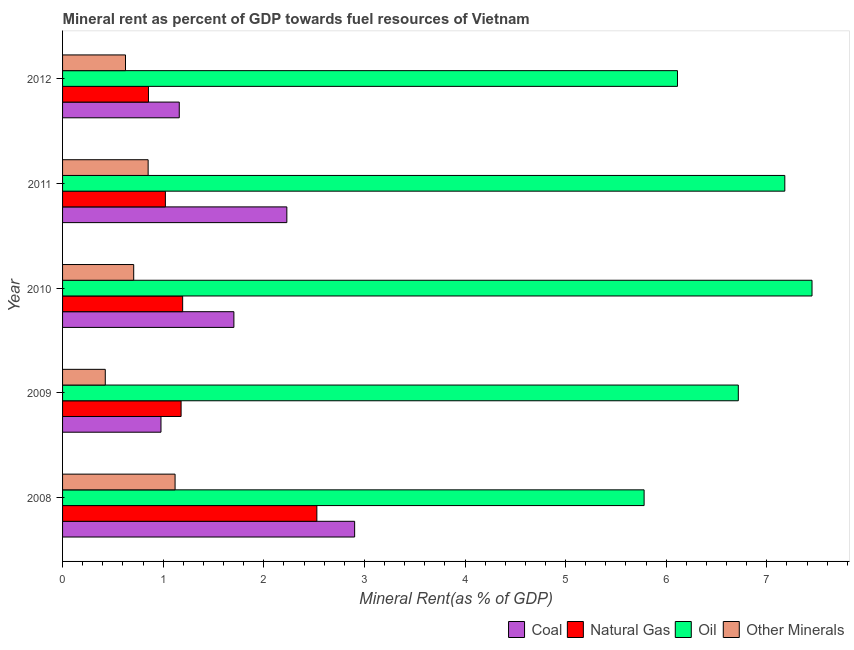How many different coloured bars are there?
Provide a succinct answer. 4. Are the number of bars on each tick of the Y-axis equal?
Offer a terse response. Yes. In how many cases, is the number of bars for a given year not equal to the number of legend labels?
Give a very brief answer. 0. What is the oil rent in 2011?
Provide a short and direct response. 7.18. Across all years, what is the maximum oil rent?
Offer a terse response. 7.45. Across all years, what is the minimum coal rent?
Provide a short and direct response. 0.98. What is the total oil rent in the graph?
Keep it short and to the point. 33.24. What is the difference between the natural gas rent in 2010 and that in 2011?
Make the answer very short. 0.17. What is the difference between the natural gas rent in 2009 and the oil rent in 2011?
Offer a very short reply. -6. What is the average natural gas rent per year?
Give a very brief answer. 1.35. In the year 2008, what is the difference between the oil rent and natural gas rent?
Ensure brevity in your answer.  3.25. What is the ratio of the  rent of other minerals in 2011 to that in 2012?
Offer a very short reply. 1.36. Is the natural gas rent in 2009 less than that in 2012?
Offer a terse response. No. Is the difference between the natural gas rent in 2008 and 2009 greater than the difference between the  rent of other minerals in 2008 and 2009?
Offer a terse response. Yes. What is the difference between the highest and the second highest natural gas rent?
Keep it short and to the point. 1.33. What is the difference between the highest and the lowest coal rent?
Provide a short and direct response. 1.92. What does the 3rd bar from the top in 2008 represents?
Make the answer very short. Natural Gas. What does the 1st bar from the bottom in 2010 represents?
Your answer should be very brief. Coal. Is it the case that in every year, the sum of the coal rent and natural gas rent is greater than the oil rent?
Ensure brevity in your answer.  No. How many years are there in the graph?
Give a very brief answer. 5. Are the values on the major ticks of X-axis written in scientific E-notation?
Your response must be concise. No. Does the graph contain any zero values?
Your response must be concise. No. Does the graph contain grids?
Your answer should be very brief. No. Where does the legend appear in the graph?
Keep it short and to the point. Bottom right. What is the title of the graph?
Offer a very short reply. Mineral rent as percent of GDP towards fuel resources of Vietnam. Does "CO2 damage" appear as one of the legend labels in the graph?
Your answer should be very brief. No. What is the label or title of the X-axis?
Offer a very short reply. Mineral Rent(as % of GDP). What is the label or title of the Y-axis?
Your response must be concise. Year. What is the Mineral Rent(as % of GDP) of Coal in 2008?
Offer a terse response. 2.9. What is the Mineral Rent(as % of GDP) of Natural Gas in 2008?
Your answer should be compact. 2.53. What is the Mineral Rent(as % of GDP) of Oil in 2008?
Offer a terse response. 5.78. What is the Mineral Rent(as % of GDP) in Other Minerals in 2008?
Ensure brevity in your answer.  1.12. What is the Mineral Rent(as % of GDP) in Coal in 2009?
Your answer should be compact. 0.98. What is the Mineral Rent(as % of GDP) of Natural Gas in 2009?
Offer a terse response. 1.18. What is the Mineral Rent(as % of GDP) in Oil in 2009?
Your response must be concise. 6.72. What is the Mineral Rent(as % of GDP) of Other Minerals in 2009?
Provide a short and direct response. 0.42. What is the Mineral Rent(as % of GDP) of Coal in 2010?
Offer a terse response. 1.7. What is the Mineral Rent(as % of GDP) in Natural Gas in 2010?
Give a very brief answer. 1.19. What is the Mineral Rent(as % of GDP) of Oil in 2010?
Offer a very short reply. 7.45. What is the Mineral Rent(as % of GDP) in Other Minerals in 2010?
Keep it short and to the point. 0.71. What is the Mineral Rent(as % of GDP) in Coal in 2011?
Keep it short and to the point. 2.23. What is the Mineral Rent(as % of GDP) of Natural Gas in 2011?
Provide a succinct answer. 1.02. What is the Mineral Rent(as % of GDP) in Oil in 2011?
Ensure brevity in your answer.  7.18. What is the Mineral Rent(as % of GDP) of Other Minerals in 2011?
Offer a terse response. 0.85. What is the Mineral Rent(as % of GDP) of Coal in 2012?
Provide a short and direct response. 1.16. What is the Mineral Rent(as % of GDP) in Natural Gas in 2012?
Ensure brevity in your answer.  0.85. What is the Mineral Rent(as % of GDP) of Oil in 2012?
Ensure brevity in your answer.  6.11. What is the Mineral Rent(as % of GDP) in Other Minerals in 2012?
Make the answer very short. 0.63. Across all years, what is the maximum Mineral Rent(as % of GDP) of Coal?
Make the answer very short. 2.9. Across all years, what is the maximum Mineral Rent(as % of GDP) of Natural Gas?
Provide a succinct answer. 2.53. Across all years, what is the maximum Mineral Rent(as % of GDP) of Oil?
Offer a very short reply. 7.45. Across all years, what is the maximum Mineral Rent(as % of GDP) of Other Minerals?
Offer a very short reply. 1.12. Across all years, what is the minimum Mineral Rent(as % of GDP) in Coal?
Make the answer very short. 0.98. Across all years, what is the minimum Mineral Rent(as % of GDP) in Natural Gas?
Offer a terse response. 0.85. Across all years, what is the minimum Mineral Rent(as % of GDP) of Oil?
Your answer should be compact. 5.78. Across all years, what is the minimum Mineral Rent(as % of GDP) of Other Minerals?
Your answer should be very brief. 0.42. What is the total Mineral Rent(as % of GDP) of Coal in the graph?
Ensure brevity in your answer.  8.97. What is the total Mineral Rent(as % of GDP) of Natural Gas in the graph?
Keep it short and to the point. 6.78. What is the total Mineral Rent(as % of GDP) of Oil in the graph?
Your answer should be compact. 33.24. What is the total Mineral Rent(as % of GDP) of Other Minerals in the graph?
Your answer should be very brief. 3.73. What is the difference between the Mineral Rent(as % of GDP) of Coal in 2008 and that in 2009?
Give a very brief answer. 1.92. What is the difference between the Mineral Rent(as % of GDP) in Natural Gas in 2008 and that in 2009?
Your answer should be compact. 1.35. What is the difference between the Mineral Rent(as % of GDP) in Oil in 2008 and that in 2009?
Your answer should be very brief. -0.94. What is the difference between the Mineral Rent(as % of GDP) in Other Minerals in 2008 and that in 2009?
Make the answer very short. 0.69. What is the difference between the Mineral Rent(as % of GDP) in Coal in 2008 and that in 2010?
Offer a terse response. 1.2. What is the difference between the Mineral Rent(as % of GDP) in Natural Gas in 2008 and that in 2010?
Offer a very short reply. 1.33. What is the difference between the Mineral Rent(as % of GDP) in Oil in 2008 and that in 2010?
Your response must be concise. -1.67. What is the difference between the Mineral Rent(as % of GDP) of Other Minerals in 2008 and that in 2010?
Your answer should be very brief. 0.41. What is the difference between the Mineral Rent(as % of GDP) in Coal in 2008 and that in 2011?
Provide a short and direct response. 0.67. What is the difference between the Mineral Rent(as % of GDP) in Natural Gas in 2008 and that in 2011?
Provide a succinct answer. 1.51. What is the difference between the Mineral Rent(as % of GDP) in Oil in 2008 and that in 2011?
Your answer should be compact. -1.4. What is the difference between the Mineral Rent(as % of GDP) of Other Minerals in 2008 and that in 2011?
Offer a very short reply. 0.27. What is the difference between the Mineral Rent(as % of GDP) in Coal in 2008 and that in 2012?
Give a very brief answer. 1.74. What is the difference between the Mineral Rent(as % of GDP) in Natural Gas in 2008 and that in 2012?
Provide a short and direct response. 1.67. What is the difference between the Mineral Rent(as % of GDP) of Oil in 2008 and that in 2012?
Provide a succinct answer. -0.33. What is the difference between the Mineral Rent(as % of GDP) in Other Minerals in 2008 and that in 2012?
Offer a terse response. 0.49. What is the difference between the Mineral Rent(as % of GDP) of Coal in 2009 and that in 2010?
Provide a succinct answer. -0.72. What is the difference between the Mineral Rent(as % of GDP) in Natural Gas in 2009 and that in 2010?
Your answer should be very brief. -0.02. What is the difference between the Mineral Rent(as % of GDP) in Oil in 2009 and that in 2010?
Keep it short and to the point. -0.73. What is the difference between the Mineral Rent(as % of GDP) of Other Minerals in 2009 and that in 2010?
Your answer should be very brief. -0.28. What is the difference between the Mineral Rent(as % of GDP) of Coal in 2009 and that in 2011?
Your answer should be very brief. -1.25. What is the difference between the Mineral Rent(as % of GDP) of Natural Gas in 2009 and that in 2011?
Give a very brief answer. 0.16. What is the difference between the Mineral Rent(as % of GDP) of Oil in 2009 and that in 2011?
Ensure brevity in your answer.  -0.46. What is the difference between the Mineral Rent(as % of GDP) in Other Minerals in 2009 and that in 2011?
Your answer should be very brief. -0.43. What is the difference between the Mineral Rent(as % of GDP) in Coal in 2009 and that in 2012?
Give a very brief answer. -0.18. What is the difference between the Mineral Rent(as % of GDP) of Natural Gas in 2009 and that in 2012?
Provide a short and direct response. 0.32. What is the difference between the Mineral Rent(as % of GDP) of Oil in 2009 and that in 2012?
Offer a very short reply. 0.6. What is the difference between the Mineral Rent(as % of GDP) in Other Minerals in 2009 and that in 2012?
Provide a short and direct response. -0.2. What is the difference between the Mineral Rent(as % of GDP) of Coal in 2010 and that in 2011?
Your answer should be very brief. -0.53. What is the difference between the Mineral Rent(as % of GDP) of Natural Gas in 2010 and that in 2011?
Provide a succinct answer. 0.17. What is the difference between the Mineral Rent(as % of GDP) of Oil in 2010 and that in 2011?
Your answer should be compact. 0.27. What is the difference between the Mineral Rent(as % of GDP) of Other Minerals in 2010 and that in 2011?
Give a very brief answer. -0.14. What is the difference between the Mineral Rent(as % of GDP) in Coal in 2010 and that in 2012?
Your answer should be compact. 0.54. What is the difference between the Mineral Rent(as % of GDP) of Natural Gas in 2010 and that in 2012?
Your answer should be very brief. 0.34. What is the difference between the Mineral Rent(as % of GDP) in Oil in 2010 and that in 2012?
Your answer should be very brief. 1.34. What is the difference between the Mineral Rent(as % of GDP) of Other Minerals in 2010 and that in 2012?
Keep it short and to the point. 0.08. What is the difference between the Mineral Rent(as % of GDP) in Coal in 2011 and that in 2012?
Ensure brevity in your answer.  1.07. What is the difference between the Mineral Rent(as % of GDP) of Natural Gas in 2011 and that in 2012?
Make the answer very short. 0.17. What is the difference between the Mineral Rent(as % of GDP) of Oil in 2011 and that in 2012?
Offer a terse response. 1.07. What is the difference between the Mineral Rent(as % of GDP) of Other Minerals in 2011 and that in 2012?
Make the answer very short. 0.22. What is the difference between the Mineral Rent(as % of GDP) in Coal in 2008 and the Mineral Rent(as % of GDP) in Natural Gas in 2009?
Offer a very short reply. 1.72. What is the difference between the Mineral Rent(as % of GDP) in Coal in 2008 and the Mineral Rent(as % of GDP) in Oil in 2009?
Offer a terse response. -3.81. What is the difference between the Mineral Rent(as % of GDP) of Coal in 2008 and the Mineral Rent(as % of GDP) of Other Minerals in 2009?
Offer a terse response. 2.48. What is the difference between the Mineral Rent(as % of GDP) of Natural Gas in 2008 and the Mineral Rent(as % of GDP) of Oil in 2009?
Give a very brief answer. -4.19. What is the difference between the Mineral Rent(as % of GDP) in Natural Gas in 2008 and the Mineral Rent(as % of GDP) in Other Minerals in 2009?
Keep it short and to the point. 2.1. What is the difference between the Mineral Rent(as % of GDP) in Oil in 2008 and the Mineral Rent(as % of GDP) in Other Minerals in 2009?
Your response must be concise. 5.36. What is the difference between the Mineral Rent(as % of GDP) in Coal in 2008 and the Mineral Rent(as % of GDP) in Natural Gas in 2010?
Your answer should be compact. 1.71. What is the difference between the Mineral Rent(as % of GDP) of Coal in 2008 and the Mineral Rent(as % of GDP) of Oil in 2010?
Offer a terse response. -4.55. What is the difference between the Mineral Rent(as % of GDP) of Coal in 2008 and the Mineral Rent(as % of GDP) of Other Minerals in 2010?
Offer a very short reply. 2.2. What is the difference between the Mineral Rent(as % of GDP) in Natural Gas in 2008 and the Mineral Rent(as % of GDP) in Oil in 2010?
Make the answer very short. -4.92. What is the difference between the Mineral Rent(as % of GDP) of Natural Gas in 2008 and the Mineral Rent(as % of GDP) of Other Minerals in 2010?
Make the answer very short. 1.82. What is the difference between the Mineral Rent(as % of GDP) of Oil in 2008 and the Mineral Rent(as % of GDP) of Other Minerals in 2010?
Provide a short and direct response. 5.07. What is the difference between the Mineral Rent(as % of GDP) of Coal in 2008 and the Mineral Rent(as % of GDP) of Natural Gas in 2011?
Your response must be concise. 1.88. What is the difference between the Mineral Rent(as % of GDP) in Coal in 2008 and the Mineral Rent(as % of GDP) in Oil in 2011?
Provide a short and direct response. -4.28. What is the difference between the Mineral Rent(as % of GDP) of Coal in 2008 and the Mineral Rent(as % of GDP) of Other Minerals in 2011?
Keep it short and to the point. 2.05. What is the difference between the Mineral Rent(as % of GDP) of Natural Gas in 2008 and the Mineral Rent(as % of GDP) of Oil in 2011?
Provide a succinct answer. -4.65. What is the difference between the Mineral Rent(as % of GDP) in Natural Gas in 2008 and the Mineral Rent(as % of GDP) in Other Minerals in 2011?
Offer a very short reply. 1.68. What is the difference between the Mineral Rent(as % of GDP) in Oil in 2008 and the Mineral Rent(as % of GDP) in Other Minerals in 2011?
Provide a succinct answer. 4.93. What is the difference between the Mineral Rent(as % of GDP) in Coal in 2008 and the Mineral Rent(as % of GDP) in Natural Gas in 2012?
Offer a very short reply. 2.05. What is the difference between the Mineral Rent(as % of GDP) of Coal in 2008 and the Mineral Rent(as % of GDP) of Oil in 2012?
Your answer should be very brief. -3.21. What is the difference between the Mineral Rent(as % of GDP) in Coal in 2008 and the Mineral Rent(as % of GDP) in Other Minerals in 2012?
Offer a terse response. 2.28. What is the difference between the Mineral Rent(as % of GDP) in Natural Gas in 2008 and the Mineral Rent(as % of GDP) in Oil in 2012?
Ensure brevity in your answer.  -3.58. What is the difference between the Mineral Rent(as % of GDP) of Natural Gas in 2008 and the Mineral Rent(as % of GDP) of Other Minerals in 2012?
Provide a short and direct response. 1.9. What is the difference between the Mineral Rent(as % of GDP) of Oil in 2008 and the Mineral Rent(as % of GDP) of Other Minerals in 2012?
Your answer should be compact. 5.15. What is the difference between the Mineral Rent(as % of GDP) of Coal in 2009 and the Mineral Rent(as % of GDP) of Natural Gas in 2010?
Your response must be concise. -0.22. What is the difference between the Mineral Rent(as % of GDP) of Coal in 2009 and the Mineral Rent(as % of GDP) of Oil in 2010?
Your answer should be very brief. -6.47. What is the difference between the Mineral Rent(as % of GDP) in Coal in 2009 and the Mineral Rent(as % of GDP) in Other Minerals in 2010?
Ensure brevity in your answer.  0.27. What is the difference between the Mineral Rent(as % of GDP) of Natural Gas in 2009 and the Mineral Rent(as % of GDP) of Oil in 2010?
Offer a terse response. -6.27. What is the difference between the Mineral Rent(as % of GDP) of Natural Gas in 2009 and the Mineral Rent(as % of GDP) of Other Minerals in 2010?
Keep it short and to the point. 0.47. What is the difference between the Mineral Rent(as % of GDP) of Oil in 2009 and the Mineral Rent(as % of GDP) of Other Minerals in 2010?
Offer a terse response. 6.01. What is the difference between the Mineral Rent(as % of GDP) of Coal in 2009 and the Mineral Rent(as % of GDP) of Natural Gas in 2011?
Your answer should be very brief. -0.04. What is the difference between the Mineral Rent(as % of GDP) of Coal in 2009 and the Mineral Rent(as % of GDP) of Oil in 2011?
Your answer should be compact. -6.2. What is the difference between the Mineral Rent(as % of GDP) of Coal in 2009 and the Mineral Rent(as % of GDP) of Other Minerals in 2011?
Keep it short and to the point. 0.13. What is the difference between the Mineral Rent(as % of GDP) of Natural Gas in 2009 and the Mineral Rent(as % of GDP) of Oil in 2011?
Provide a short and direct response. -6. What is the difference between the Mineral Rent(as % of GDP) of Natural Gas in 2009 and the Mineral Rent(as % of GDP) of Other Minerals in 2011?
Your response must be concise. 0.33. What is the difference between the Mineral Rent(as % of GDP) of Oil in 2009 and the Mineral Rent(as % of GDP) of Other Minerals in 2011?
Your answer should be compact. 5.87. What is the difference between the Mineral Rent(as % of GDP) in Coal in 2009 and the Mineral Rent(as % of GDP) in Natural Gas in 2012?
Provide a succinct answer. 0.12. What is the difference between the Mineral Rent(as % of GDP) in Coal in 2009 and the Mineral Rent(as % of GDP) in Oil in 2012?
Provide a short and direct response. -5.13. What is the difference between the Mineral Rent(as % of GDP) in Coal in 2009 and the Mineral Rent(as % of GDP) in Other Minerals in 2012?
Keep it short and to the point. 0.35. What is the difference between the Mineral Rent(as % of GDP) of Natural Gas in 2009 and the Mineral Rent(as % of GDP) of Oil in 2012?
Provide a short and direct response. -4.93. What is the difference between the Mineral Rent(as % of GDP) of Natural Gas in 2009 and the Mineral Rent(as % of GDP) of Other Minerals in 2012?
Offer a very short reply. 0.55. What is the difference between the Mineral Rent(as % of GDP) of Oil in 2009 and the Mineral Rent(as % of GDP) of Other Minerals in 2012?
Provide a short and direct response. 6.09. What is the difference between the Mineral Rent(as % of GDP) of Coal in 2010 and the Mineral Rent(as % of GDP) of Natural Gas in 2011?
Provide a short and direct response. 0.68. What is the difference between the Mineral Rent(as % of GDP) of Coal in 2010 and the Mineral Rent(as % of GDP) of Oil in 2011?
Offer a terse response. -5.48. What is the difference between the Mineral Rent(as % of GDP) of Coal in 2010 and the Mineral Rent(as % of GDP) of Other Minerals in 2011?
Ensure brevity in your answer.  0.85. What is the difference between the Mineral Rent(as % of GDP) in Natural Gas in 2010 and the Mineral Rent(as % of GDP) in Oil in 2011?
Give a very brief answer. -5.99. What is the difference between the Mineral Rent(as % of GDP) in Natural Gas in 2010 and the Mineral Rent(as % of GDP) in Other Minerals in 2011?
Ensure brevity in your answer.  0.34. What is the difference between the Mineral Rent(as % of GDP) in Oil in 2010 and the Mineral Rent(as % of GDP) in Other Minerals in 2011?
Ensure brevity in your answer.  6.6. What is the difference between the Mineral Rent(as % of GDP) in Coal in 2010 and the Mineral Rent(as % of GDP) in Natural Gas in 2012?
Offer a terse response. 0.85. What is the difference between the Mineral Rent(as % of GDP) in Coal in 2010 and the Mineral Rent(as % of GDP) in Oil in 2012?
Ensure brevity in your answer.  -4.41. What is the difference between the Mineral Rent(as % of GDP) in Coal in 2010 and the Mineral Rent(as % of GDP) in Other Minerals in 2012?
Provide a short and direct response. 1.08. What is the difference between the Mineral Rent(as % of GDP) of Natural Gas in 2010 and the Mineral Rent(as % of GDP) of Oil in 2012?
Provide a succinct answer. -4.92. What is the difference between the Mineral Rent(as % of GDP) in Natural Gas in 2010 and the Mineral Rent(as % of GDP) in Other Minerals in 2012?
Your response must be concise. 0.57. What is the difference between the Mineral Rent(as % of GDP) in Oil in 2010 and the Mineral Rent(as % of GDP) in Other Minerals in 2012?
Provide a succinct answer. 6.82. What is the difference between the Mineral Rent(as % of GDP) in Coal in 2011 and the Mineral Rent(as % of GDP) in Natural Gas in 2012?
Ensure brevity in your answer.  1.38. What is the difference between the Mineral Rent(as % of GDP) of Coal in 2011 and the Mineral Rent(as % of GDP) of Oil in 2012?
Offer a very short reply. -3.88. What is the difference between the Mineral Rent(as % of GDP) of Coal in 2011 and the Mineral Rent(as % of GDP) of Other Minerals in 2012?
Your response must be concise. 1.6. What is the difference between the Mineral Rent(as % of GDP) of Natural Gas in 2011 and the Mineral Rent(as % of GDP) of Oil in 2012?
Provide a succinct answer. -5.09. What is the difference between the Mineral Rent(as % of GDP) in Natural Gas in 2011 and the Mineral Rent(as % of GDP) in Other Minerals in 2012?
Offer a very short reply. 0.4. What is the difference between the Mineral Rent(as % of GDP) in Oil in 2011 and the Mineral Rent(as % of GDP) in Other Minerals in 2012?
Offer a very short reply. 6.55. What is the average Mineral Rent(as % of GDP) in Coal per year?
Your answer should be compact. 1.79. What is the average Mineral Rent(as % of GDP) in Natural Gas per year?
Your response must be concise. 1.35. What is the average Mineral Rent(as % of GDP) of Oil per year?
Give a very brief answer. 6.65. What is the average Mineral Rent(as % of GDP) in Other Minerals per year?
Your response must be concise. 0.75. In the year 2008, what is the difference between the Mineral Rent(as % of GDP) of Coal and Mineral Rent(as % of GDP) of Natural Gas?
Your answer should be very brief. 0.38. In the year 2008, what is the difference between the Mineral Rent(as % of GDP) of Coal and Mineral Rent(as % of GDP) of Oil?
Your answer should be compact. -2.88. In the year 2008, what is the difference between the Mineral Rent(as % of GDP) of Coal and Mineral Rent(as % of GDP) of Other Minerals?
Provide a succinct answer. 1.78. In the year 2008, what is the difference between the Mineral Rent(as % of GDP) in Natural Gas and Mineral Rent(as % of GDP) in Oil?
Offer a terse response. -3.25. In the year 2008, what is the difference between the Mineral Rent(as % of GDP) in Natural Gas and Mineral Rent(as % of GDP) in Other Minerals?
Offer a very short reply. 1.41. In the year 2008, what is the difference between the Mineral Rent(as % of GDP) of Oil and Mineral Rent(as % of GDP) of Other Minerals?
Make the answer very short. 4.66. In the year 2009, what is the difference between the Mineral Rent(as % of GDP) of Coal and Mineral Rent(as % of GDP) of Natural Gas?
Your answer should be very brief. -0.2. In the year 2009, what is the difference between the Mineral Rent(as % of GDP) in Coal and Mineral Rent(as % of GDP) in Oil?
Offer a terse response. -5.74. In the year 2009, what is the difference between the Mineral Rent(as % of GDP) of Coal and Mineral Rent(as % of GDP) of Other Minerals?
Your answer should be compact. 0.55. In the year 2009, what is the difference between the Mineral Rent(as % of GDP) in Natural Gas and Mineral Rent(as % of GDP) in Oil?
Provide a short and direct response. -5.54. In the year 2009, what is the difference between the Mineral Rent(as % of GDP) of Natural Gas and Mineral Rent(as % of GDP) of Other Minerals?
Your response must be concise. 0.75. In the year 2009, what is the difference between the Mineral Rent(as % of GDP) of Oil and Mineral Rent(as % of GDP) of Other Minerals?
Your answer should be very brief. 6.29. In the year 2010, what is the difference between the Mineral Rent(as % of GDP) of Coal and Mineral Rent(as % of GDP) of Natural Gas?
Ensure brevity in your answer.  0.51. In the year 2010, what is the difference between the Mineral Rent(as % of GDP) in Coal and Mineral Rent(as % of GDP) in Oil?
Ensure brevity in your answer.  -5.75. In the year 2010, what is the difference between the Mineral Rent(as % of GDP) in Natural Gas and Mineral Rent(as % of GDP) in Oil?
Your answer should be very brief. -6.26. In the year 2010, what is the difference between the Mineral Rent(as % of GDP) of Natural Gas and Mineral Rent(as % of GDP) of Other Minerals?
Make the answer very short. 0.49. In the year 2010, what is the difference between the Mineral Rent(as % of GDP) of Oil and Mineral Rent(as % of GDP) of Other Minerals?
Make the answer very short. 6.74. In the year 2011, what is the difference between the Mineral Rent(as % of GDP) in Coal and Mineral Rent(as % of GDP) in Natural Gas?
Give a very brief answer. 1.21. In the year 2011, what is the difference between the Mineral Rent(as % of GDP) of Coal and Mineral Rent(as % of GDP) of Oil?
Provide a short and direct response. -4.95. In the year 2011, what is the difference between the Mineral Rent(as % of GDP) in Coal and Mineral Rent(as % of GDP) in Other Minerals?
Offer a very short reply. 1.38. In the year 2011, what is the difference between the Mineral Rent(as % of GDP) of Natural Gas and Mineral Rent(as % of GDP) of Oil?
Your answer should be compact. -6.16. In the year 2011, what is the difference between the Mineral Rent(as % of GDP) in Natural Gas and Mineral Rent(as % of GDP) in Other Minerals?
Provide a short and direct response. 0.17. In the year 2011, what is the difference between the Mineral Rent(as % of GDP) in Oil and Mineral Rent(as % of GDP) in Other Minerals?
Provide a succinct answer. 6.33. In the year 2012, what is the difference between the Mineral Rent(as % of GDP) in Coal and Mineral Rent(as % of GDP) in Natural Gas?
Ensure brevity in your answer.  0.31. In the year 2012, what is the difference between the Mineral Rent(as % of GDP) of Coal and Mineral Rent(as % of GDP) of Oil?
Ensure brevity in your answer.  -4.95. In the year 2012, what is the difference between the Mineral Rent(as % of GDP) of Coal and Mineral Rent(as % of GDP) of Other Minerals?
Give a very brief answer. 0.53. In the year 2012, what is the difference between the Mineral Rent(as % of GDP) in Natural Gas and Mineral Rent(as % of GDP) in Oil?
Provide a short and direct response. -5.26. In the year 2012, what is the difference between the Mineral Rent(as % of GDP) of Natural Gas and Mineral Rent(as % of GDP) of Other Minerals?
Ensure brevity in your answer.  0.23. In the year 2012, what is the difference between the Mineral Rent(as % of GDP) of Oil and Mineral Rent(as % of GDP) of Other Minerals?
Keep it short and to the point. 5.49. What is the ratio of the Mineral Rent(as % of GDP) of Coal in 2008 to that in 2009?
Give a very brief answer. 2.97. What is the ratio of the Mineral Rent(as % of GDP) in Natural Gas in 2008 to that in 2009?
Provide a succinct answer. 2.15. What is the ratio of the Mineral Rent(as % of GDP) in Oil in 2008 to that in 2009?
Offer a very short reply. 0.86. What is the ratio of the Mineral Rent(as % of GDP) of Other Minerals in 2008 to that in 2009?
Provide a short and direct response. 2.63. What is the ratio of the Mineral Rent(as % of GDP) of Coal in 2008 to that in 2010?
Give a very brief answer. 1.7. What is the ratio of the Mineral Rent(as % of GDP) of Natural Gas in 2008 to that in 2010?
Your answer should be compact. 2.12. What is the ratio of the Mineral Rent(as % of GDP) of Oil in 2008 to that in 2010?
Your answer should be compact. 0.78. What is the ratio of the Mineral Rent(as % of GDP) of Other Minerals in 2008 to that in 2010?
Your answer should be very brief. 1.58. What is the ratio of the Mineral Rent(as % of GDP) in Coal in 2008 to that in 2011?
Ensure brevity in your answer.  1.3. What is the ratio of the Mineral Rent(as % of GDP) of Natural Gas in 2008 to that in 2011?
Offer a very short reply. 2.47. What is the ratio of the Mineral Rent(as % of GDP) in Oil in 2008 to that in 2011?
Provide a succinct answer. 0.81. What is the ratio of the Mineral Rent(as % of GDP) in Other Minerals in 2008 to that in 2011?
Keep it short and to the point. 1.31. What is the ratio of the Mineral Rent(as % of GDP) in Coal in 2008 to that in 2012?
Ensure brevity in your answer.  2.5. What is the ratio of the Mineral Rent(as % of GDP) of Natural Gas in 2008 to that in 2012?
Offer a very short reply. 2.96. What is the ratio of the Mineral Rent(as % of GDP) in Oil in 2008 to that in 2012?
Offer a terse response. 0.95. What is the ratio of the Mineral Rent(as % of GDP) in Other Minerals in 2008 to that in 2012?
Ensure brevity in your answer.  1.79. What is the ratio of the Mineral Rent(as % of GDP) of Coal in 2009 to that in 2010?
Offer a terse response. 0.57. What is the ratio of the Mineral Rent(as % of GDP) of Natural Gas in 2009 to that in 2010?
Offer a very short reply. 0.99. What is the ratio of the Mineral Rent(as % of GDP) of Oil in 2009 to that in 2010?
Offer a very short reply. 0.9. What is the ratio of the Mineral Rent(as % of GDP) of Other Minerals in 2009 to that in 2010?
Provide a succinct answer. 0.6. What is the ratio of the Mineral Rent(as % of GDP) in Coal in 2009 to that in 2011?
Provide a short and direct response. 0.44. What is the ratio of the Mineral Rent(as % of GDP) in Natural Gas in 2009 to that in 2011?
Provide a short and direct response. 1.15. What is the ratio of the Mineral Rent(as % of GDP) of Oil in 2009 to that in 2011?
Make the answer very short. 0.94. What is the ratio of the Mineral Rent(as % of GDP) of Other Minerals in 2009 to that in 2011?
Provide a succinct answer. 0.5. What is the ratio of the Mineral Rent(as % of GDP) of Coal in 2009 to that in 2012?
Keep it short and to the point. 0.84. What is the ratio of the Mineral Rent(as % of GDP) of Natural Gas in 2009 to that in 2012?
Give a very brief answer. 1.38. What is the ratio of the Mineral Rent(as % of GDP) of Oil in 2009 to that in 2012?
Your answer should be very brief. 1.1. What is the ratio of the Mineral Rent(as % of GDP) of Other Minerals in 2009 to that in 2012?
Keep it short and to the point. 0.68. What is the ratio of the Mineral Rent(as % of GDP) of Coal in 2010 to that in 2011?
Your answer should be very brief. 0.76. What is the ratio of the Mineral Rent(as % of GDP) in Natural Gas in 2010 to that in 2011?
Your response must be concise. 1.17. What is the ratio of the Mineral Rent(as % of GDP) in Oil in 2010 to that in 2011?
Ensure brevity in your answer.  1.04. What is the ratio of the Mineral Rent(as % of GDP) of Other Minerals in 2010 to that in 2011?
Give a very brief answer. 0.83. What is the ratio of the Mineral Rent(as % of GDP) of Coal in 2010 to that in 2012?
Ensure brevity in your answer.  1.47. What is the ratio of the Mineral Rent(as % of GDP) in Natural Gas in 2010 to that in 2012?
Your response must be concise. 1.4. What is the ratio of the Mineral Rent(as % of GDP) in Oil in 2010 to that in 2012?
Your answer should be compact. 1.22. What is the ratio of the Mineral Rent(as % of GDP) of Other Minerals in 2010 to that in 2012?
Keep it short and to the point. 1.13. What is the ratio of the Mineral Rent(as % of GDP) in Coal in 2011 to that in 2012?
Keep it short and to the point. 1.92. What is the ratio of the Mineral Rent(as % of GDP) of Natural Gas in 2011 to that in 2012?
Offer a very short reply. 1.2. What is the ratio of the Mineral Rent(as % of GDP) of Oil in 2011 to that in 2012?
Ensure brevity in your answer.  1.17. What is the ratio of the Mineral Rent(as % of GDP) in Other Minerals in 2011 to that in 2012?
Make the answer very short. 1.36. What is the difference between the highest and the second highest Mineral Rent(as % of GDP) of Coal?
Keep it short and to the point. 0.67. What is the difference between the highest and the second highest Mineral Rent(as % of GDP) in Natural Gas?
Your response must be concise. 1.33. What is the difference between the highest and the second highest Mineral Rent(as % of GDP) of Oil?
Make the answer very short. 0.27. What is the difference between the highest and the second highest Mineral Rent(as % of GDP) in Other Minerals?
Ensure brevity in your answer.  0.27. What is the difference between the highest and the lowest Mineral Rent(as % of GDP) in Coal?
Provide a succinct answer. 1.92. What is the difference between the highest and the lowest Mineral Rent(as % of GDP) in Natural Gas?
Offer a terse response. 1.67. What is the difference between the highest and the lowest Mineral Rent(as % of GDP) in Oil?
Your answer should be very brief. 1.67. What is the difference between the highest and the lowest Mineral Rent(as % of GDP) of Other Minerals?
Your answer should be compact. 0.69. 